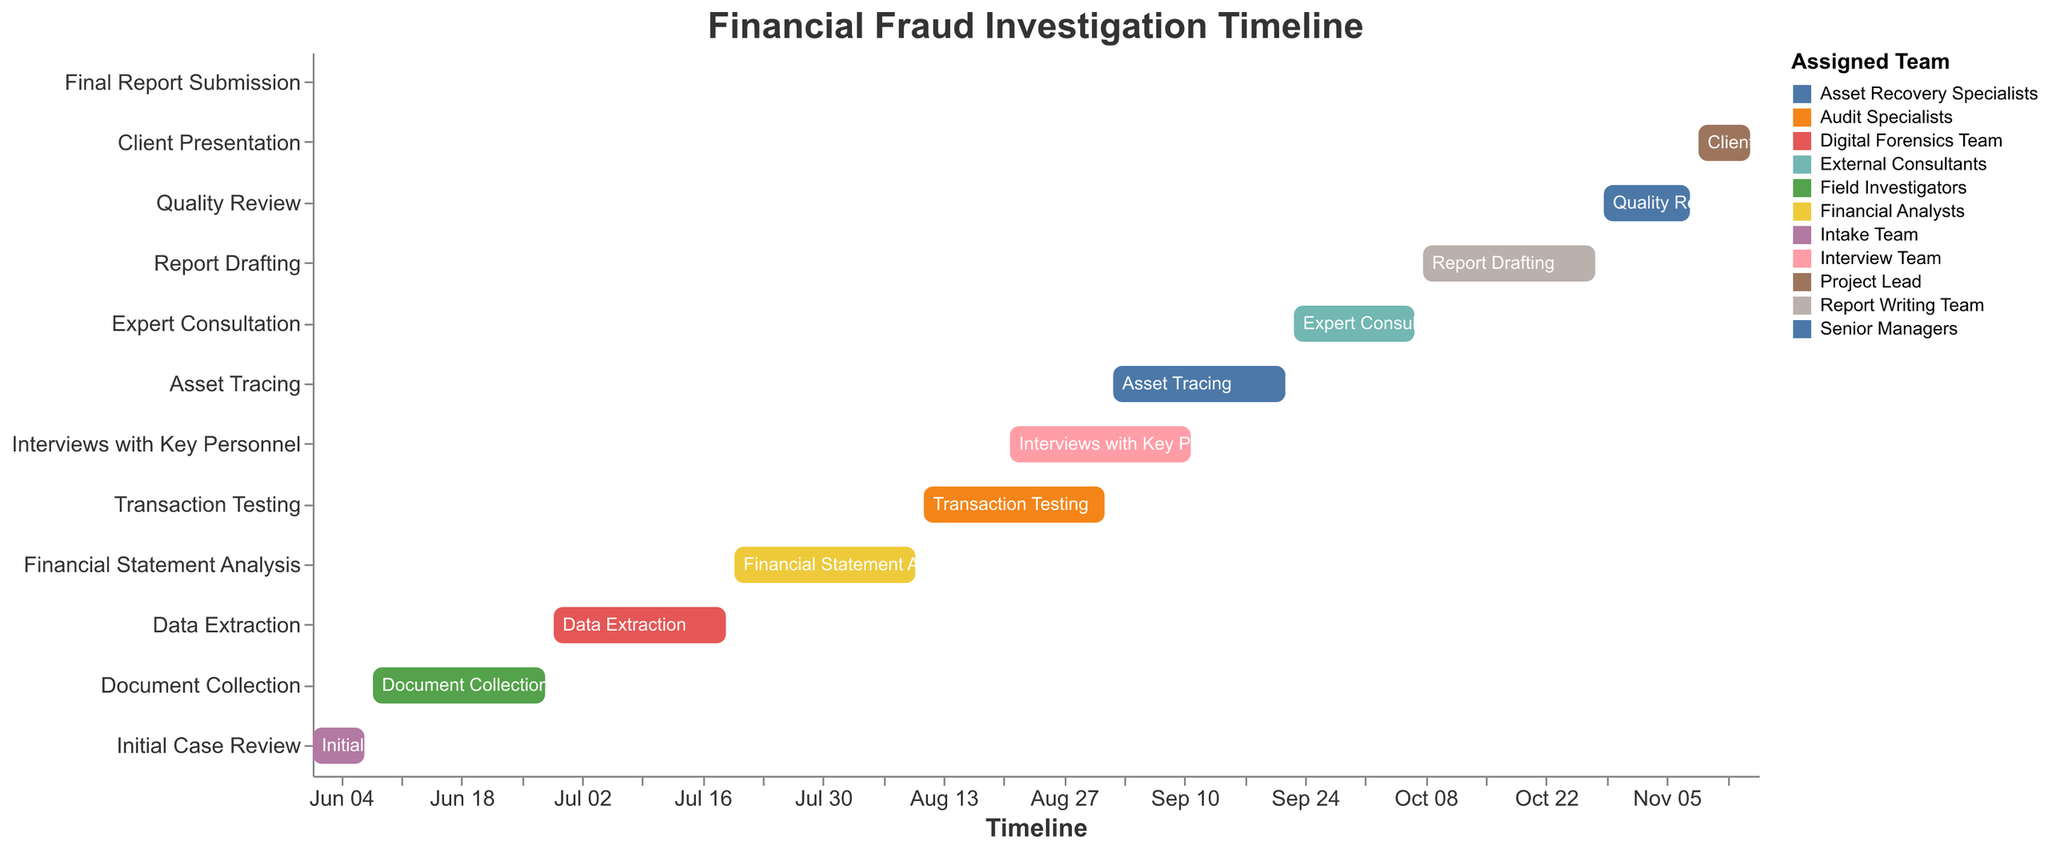What is the duration of the "Transaction Testing" task? The "Transaction Testing" task starts on August 11 and ends on September 1. To find the duration, calculate the difference between the start and end dates. From August 11 to September 1 is 21 days.
Answer: 21 days Which team is assigned to the "Asset Tracing" task? The Gantt Chart shows that the "Asset Tracing" task is assigned to the Asset Recovery Specialists team.
Answer: Asset Recovery Specialists How many tasks overlap with the "Data Extraction" task? The "Data Extraction" task runs from June 29 to July 19. Looking at the chart, no other tasks overlap with these dates.
Answer: 0 tasks What is the role of the "Financial Analysts" team? According to the chart, the "Financial Analysts" team is responsible for the "Financial Statement Analysis" task.
Answer: Financial Statement Analysis Which task has the shortest duration, and what is its duration? "Final Report Submission" has the shortest duration, spanning just one day from November 16 to November 16.
Answer: Final Report Submission, 1 day When does the "Document Collection" task start and end? The "Document Collection" task starts on June 8 and ends on June 28.
Answer: June 8 to June 28 Which task spans the longest period, and how long is it? "Transaction Testing" spans the longest period, starting from August 11 to September 1, which totals 21 days.
Answer: Transaction Testing, 21 days Which tasks are carried out simultaneously during the timeframe of August 21 to September 1? During the timeframe of August 21 to September 1, both "Transaction Testing" and "Interviews with Key Personnel" are carried out simultaneously.
Answer: "Transaction Testing" and "Interviews with Key Personnel" Compare the duration of "Report Drafting" and "Quality Review". Which is longer and by how many days? "Report Drafting" runs from October 8 to October 28, making it 20 days long. "Quality Review" runs from October 29 to November 8, making it 11 days long. The difference is 9 days.
Answer: "Report Drafting" is longer by 9 days Which tasks are assigned to the Project Lead team? The Project Lead team is responsible for "Client Presentation" and "Final Report Submission" tasks according to the chart.
Answer: "Client Presentation" and "Final Report Submission" 